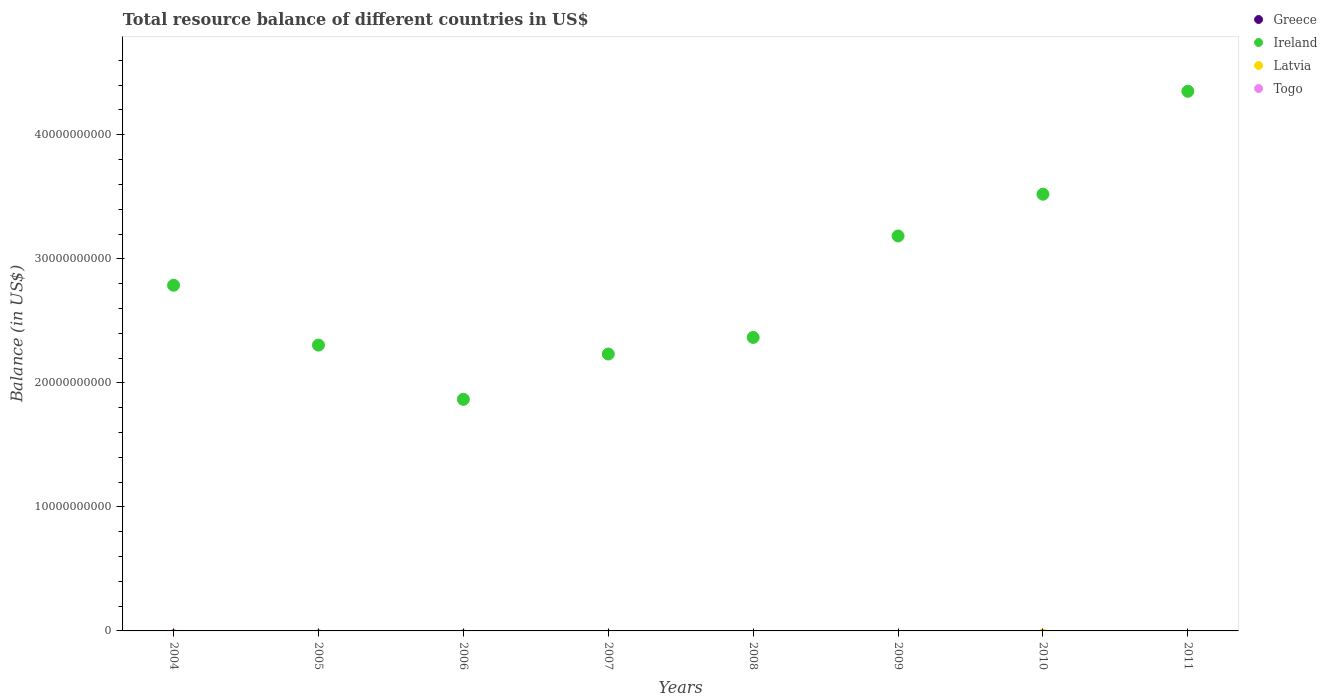Is the number of dotlines equal to the number of legend labels?
Ensure brevity in your answer.  No. What is the total resource balance in Greece in 2010?
Keep it short and to the point. 0. Across all years, what is the maximum total resource balance in Ireland?
Give a very brief answer. 4.35e+1. Across all years, what is the minimum total resource balance in Greece?
Offer a very short reply. 0. What is the total total resource balance in Greece in the graph?
Offer a very short reply. 0. What is the difference between the total resource balance in Ireland in 2006 and that in 2010?
Make the answer very short. -1.65e+1. What is the difference between the total resource balance in Ireland in 2011 and the total resource balance in Togo in 2009?
Your answer should be very brief. 4.35e+1. What is the average total resource balance in Togo per year?
Offer a terse response. 0. What is the difference between the highest and the second highest total resource balance in Ireland?
Offer a terse response. 8.30e+09. What is the difference between the highest and the lowest total resource balance in Ireland?
Ensure brevity in your answer.  2.48e+1. Is the sum of the total resource balance in Ireland in 2004 and 2006 greater than the maximum total resource balance in Greece across all years?
Keep it short and to the point. Yes. Is it the case that in every year, the sum of the total resource balance in Greece and total resource balance in Togo  is greater than the sum of total resource balance in Latvia and total resource balance in Ireland?
Offer a terse response. No. Is it the case that in every year, the sum of the total resource balance in Greece and total resource balance in Togo  is greater than the total resource balance in Ireland?
Give a very brief answer. No. Does the total resource balance in Greece monotonically increase over the years?
Ensure brevity in your answer.  No. Is the total resource balance in Latvia strictly greater than the total resource balance in Ireland over the years?
Offer a terse response. No. Is the total resource balance in Ireland strictly less than the total resource balance in Latvia over the years?
Offer a very short reply. No. What is the difference between two consecutive major ticks on the Y-axis?
Your response must be concise. 1.00e+1. Are the values on the major ticks of Y-axis written in scientific E-notation?
Give a very brief answer. No. Does the graph contain grids?
Provide a short and direct response. No. Where does the legend appear in the graph?
Make the answer very short. Top right. How many legend labels are there?
Offer a very short reply. 4. How are the legend labels stacked?
Provide a short and direct response. Vertical. What is the title of the graph?
Your response must be concise. Total resource balance of different countries in US$. Does "Egypt, Arab Rep." appear as one of the legend labels in the graph?
Keep it short and to the point. No. What is the label or title of the Y-axis?
Provide a succinct answer. Balance (in US$). What is the Balance (in US$) in Greece in 2004?
Make the answer very short. 0. What is the Balance (in US$) of Ireland in 2004?
Offer a very short reply. 2.79e+1. What is the Balance (in US$) of Latvia in 2004?
Your answer should be very brief. 0. What is the Balance (in US$) in Togo in 2004?
Provide a succinct answer. 0. What is the Balance (in US$) in Greece in 2005?
Provide a succinct answer. 0. What is the Balance (in US$) in Ireland in 2005?
Provide a short and direct response. 2.30e+1. What is the Balance (in US$) in Latvia in 2005?
Offer a terse response. 0. What is the Balance (in US$) of Greece in 2006?
Provide a short and direct response. 0. What is the Balance (in US$) of Ireland in 2006?
Give a very brief answer. 1.87e+1. What is the Balance (in US$) of Togo in 2006?
Provide a short and direct response. 0. What is the Balance (in US$) of Greece in 2007?
Your response must be concise. 0. What is the Balance (in US$) of Ireland in 2007?
Your answer should be very brief. 2.23e+1. What is the Balance (in US$) in Latvia in 2007?
Make the answer very short. 0. What is the Balance (in US$) of Greece in 2008?
Ensure brevity in your answer.  0. What is the Balance (in US$) of Ireland in 2008?
Your response must be concise. 2.37e+1. What is the Balance (in US$) of Togo in 2008?
Your answer should be compact. 0. What is the Balance (in US$) of Greece in 2009?
Give a very brief answer. 0. What is the Balance (in US$) in Ireland in 2009?
Make the answer very short. 3.18e+1. What is the Balance (in US$) in Latvia in 2009?
Your answer should be compact. 0. What is the Balance (in US$) in Togo in 2009?
Your response must be concise. 0. What is the Balance (in US$) in Ireland in 2010?
Your answer should be very brief. 3.52e+1. What is the Balance (in US$) in Latvia in 2010?
Make the answer very short. 0. What is the Balance (in US$) in Togo in 2010?
Make the answer very short. 0. What is the Balance (in US$) in Greece in 2011?
Your response must be concise. 0. What is the Balance (in US$) in Ireland in 2011?
Provide a short and direct response. 4.35e+1. What is the Balance (in US$) of Togo in 2011?
Offer a very short reply. 0. Across all years, what is the maximum Balance (in US$) in Ireland?
Keep it short and to the point. 4.35e+1. Across all years, what is the minimum Balance (in US$) in Ireland?
Provide a succinct answer. 1.87e+1. What is the total Balance (in US$) of Greece in the graph?
Ensure brevity in your answer.  0. What is the total Balance (in US$) in Ireland in the graph?
Offer a terse response. 2.26e+11. What is the total Balance (in US$) in Togo in the graph?
Ensure brevity in your answer.  0. What is the difference between the Balance (in US$) in Ireland in 2004 and that in 2005?
Provide a short and direct response. 4.83e+09. What is the difference between the Balance (in US$) in Ireland in 2004 and that in 2006?
Your answer should be compact. 9.20e+09. What is the difference between the Balance (in US$) in Ireland in 2004 and that in 2007?
Your answer should be very brief. 5.55e+09. What is the difference between the Balance (in US$) of Ireland in 2004 and that in 2008?
Make the answer very short. 4.21e+09. What is the difference between the Balance (in US$) in Ireland in 2004 and that in 2009?
Keep it short and to the point. -3.97e+09. What is the difference between the Balance (in US$) in Ireland in 2004 and that in 2010?
Offer a terse response. -7.34e+09. What is the difference between the Balance (in US$) in Ireland in 2004 and that in 2011?
Offer a very short reply. -1.56e+1. What is the difference between the Balance (in US$) of Ireland in 2005 and that in 2006?
Ensure brevity in your answer.  4.37e+09. What is the difference between the Balance (in US$) of Ireland in 2005 and that in 2007?
Keep it short and to the point. 7.20e+08. What is the difference between the Balance (in US$) in Ireland in 2005 and that in 2008?
Ensure brevity in your answer.  -6.19e+08. What is the difference between the Balance (in US$) of Ireland in 2005 and that in 2009?
Give a very brief answer. -8.80e+09. What is the difference between the Balance (in US$) of Ireland in 2005 and that in 2010?
Offer a very short reply. -1.22e+1. What is the difference between the Balance (in US$) in Ireland in 2005 and that in 2011?
Provide a short and direct response. -2.05e+1. What is the difference between the Balance (in US$) of Ireland in 2006 and that in 2007?
Your response must be concise. -3.65e+09. What is the difference between the Balance (in US$) of Ireland in 2006 and that in 2008?
Keep it short and to the point. -4.99e+09. What is the difference between the Balance (in US$) of Ireland in 2006 and that in 2009?
Provide a short and direct response. -1.32e+1. What is the difference between the Balance (in US$) of Ireland in 2006 and that in 2010?
Your response must be concise. -1.65e+1. What is the difference between the Balance (in US$) of Ireland in 2006 and that in 2011?
Provide a short and direct response. -2.48e+1. What is the difference between the Balance (in US$) of Ireland in 2007 and that in 2008?
Make the answer very short. -1.34e+09. What is the difference between the Balance (in US$) in Ireland in 2007 and that in 2009?
Offer a very short reply. -9.52e+09. What is the difference between the Balance (in US$) in Ireland in 2007 and that in 2010?
Offer a terse response. -1.29e+1. What is the difference between the Balance (in US$) in Ireland in 2007 and that in 2011?
Your answer should be compact. -2.12e+1. What is the difference between the Balance (in US$) in Ireland in 2008 and that in 2009?
Your answer should be compact. -8.18e+09. What is the difference between the Balance (in US$) in Ireland in 2008 and that in 2010?
Your answer should be very brief. -1.15e+1. What is the difference between the Balance (in US$) in Ireland in 2008 and that in 2011?
Your response must be concise. -1.98e+1. What is the difference between the Balance (in US$) of Ireland in 2009 and that in 2010?
Provide a short and direct response. -3.37e+09. What is the difference between the Balance (in US$) of Ireland in 2009 and that in 2011?
Offer a very short reply. -1.17e+1. What is the difference between the Balance (in US$) of Ireland in 2010 and that in 2011?
Your response must be concise. -8.30e+09. What is the average Balance (in US$) of Ireland per year?
Offer a very short reply. 2.83e+1. What is the average Balance (in US$) of Togo per year?
Your response must be concise. 0. What is the ratio of the Balance (in US$) in Ireland in 2004 to that in 2005?
Your answer should be compact. 1.21. What is the ratio of the Balance (in US$) of Ireland in 2004 to that in 2006?
Ensure brevity in your answer.  1.49. What is the ratio of the Balance (in US$) of Ireland in 2004 to that in 2007?
Your answer should be compact. 1.25. What is the ratio of the Balance (in US$) of Ireland in 2004 to that in 2008?
Provide a short and direct response. 1.18. What is the ratio of the Balance (in US$) of Ireland in 2004 to that in 2009?
Make the answer very short. 0.88. What is the ratio of the Balance (in US$) of Ireland in 2004 to that in 2010?
Your answer should be compact. 0.79. What is the ratio of the Balance (in US$) of Ireland in 2004 to that in 2011?
Offer a terse response. 0.64. What is the ratio of the Balance (in US$) of Ireland in 2005 to that in 2006?
Provide a short and direct response. 1.23. What is the ratio of the Balance (in US$) of Ireland in 2005 to that in 2007?
Offer a terse response. 1.03. What is the ratio of the Balance (in US$) of Ireland in 2005 to that in 2008?
Provide a succinct answer. 0.97. What is the ratio of the Balance (in US$) of Ireland in 2005 to that in 2009?
Ensure brevity in your answer.  0.72. What is the ratio of the Balance (in US$) in Ireland in 2005 to that in 2010?
Provide a succinct answer. 0.65. What is the ratio of the Balance (in US$) in Ireland in 2005 to that in 2011?
Your response must be concise. 0.53. What is the ratio of the Balance (in US$) of Ireland in 2006 to that in 2007?
Offer a terse response. 0.84. What is the ratio of the Balance (in US$) of Ireland in 2006 to that in 2008?
Ensure brevity in your answer.  0.79. What is the ratio of the Balance (in US$) in Ireland in 2006 to that in 2009?
Give a very brief answer. 0.59. What is the ratio of the Balance (in US$) in Ireland in 2006 to that in 2010?
Ensure brevity in your answer.  0.53. What is the ratio of the Balance (in US$) of Ireland in 2006 to that in 2011?
Make the answer very short. 0.43. What is the ratio of the Balance (in US$) in Ireland in 2007 to that in 2008?
Your response must be concise. 0.94. What is the ratio of the Balance (in US$) of Ireland in 2007 to that in 2009?
Provide a short and direct response. 0.7. What is the ratio of the Balance (in US$) of Ireland in 2007 to that in 2010?
Your answer should be compact. 0.63. What is the ratio of the Balance (in US$) in Ireland in 2007 to that in 2011?
Make the answer very short. 0.51. What is the ratio of the Balance (in US$) in Ireland in 2008 to that in 2009?
Provide a short and direct response. 0.74. What is the ratio of the Balance (in US$) in Ireland in 2008 to that in 2010?
Give a very brief answer. 0.67. What is the ratio of the Balance (in US$) of Ireland in 2008 to that in 2011?
Give a very brief answer. 0.54. What is the ratio of the Balance (in US$) of Ireland in 2009 to that in 2010?
Your response must be concise. 0.9. What is the ratio of the Balance (in US$) in Ireland in 2009 to that in 2011?
Provide a succinct answer. 0.73. What is the ratio of the Balance (in US$) of Ireland in 2010 to that in 2011?
Offer a very short reply. 0.81. What is the difference between the highest and the second highest Balance (in US$) of Ireland?
Make the answer very short. 8.30e+09. What is the difference between the highest and the lowest Balance (in US$) in Ireland?
Provide a short and direct response. 2.48e+1. 